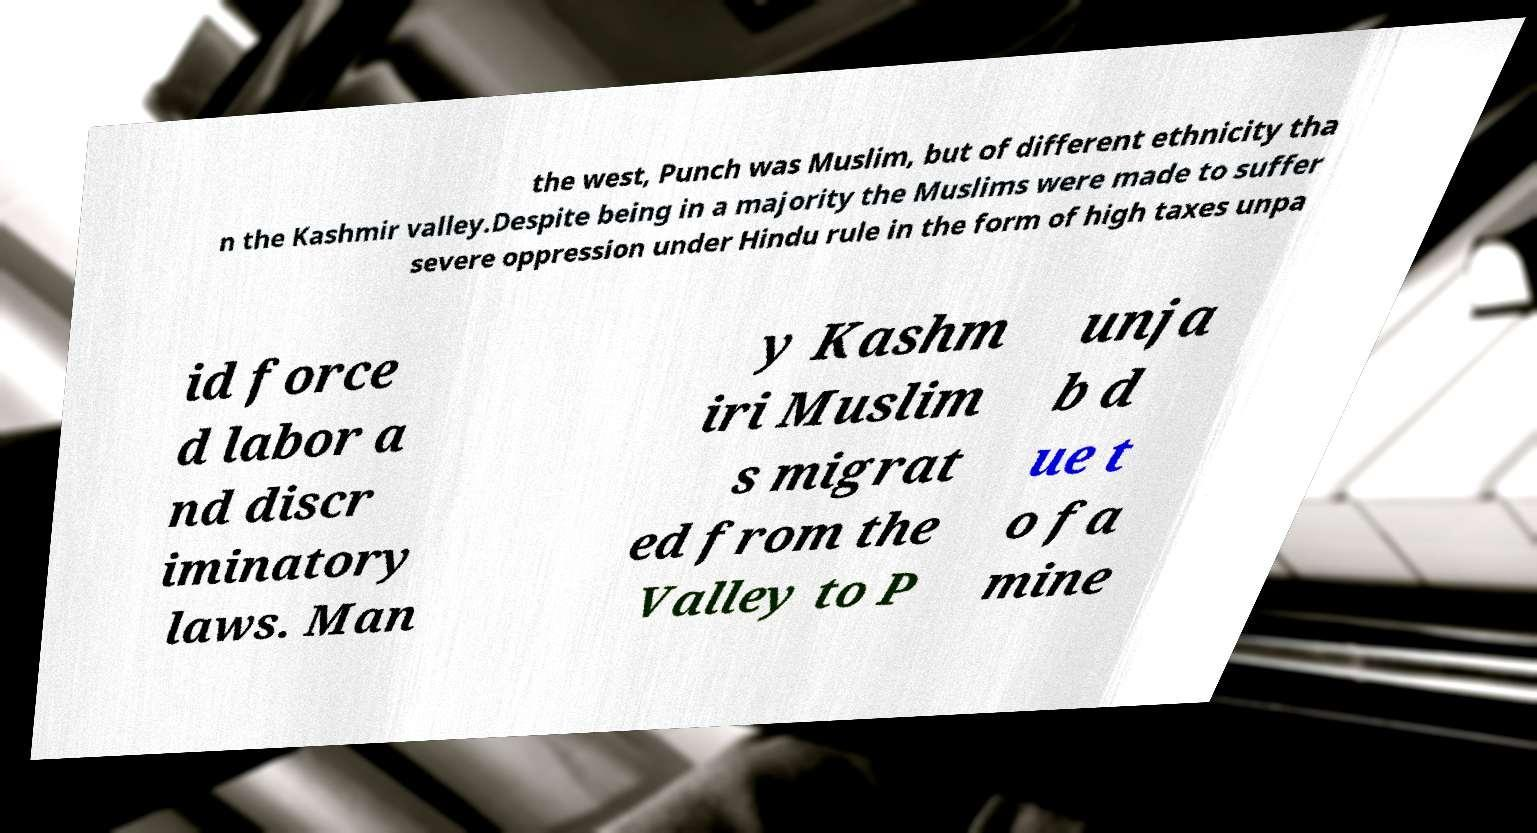What messages or text are displayed in this image? I need them in a readable, typed format. the west, Punch was Muslim, but of different ethnicity tha n the Kashmir valley.Despite being in a majority the Muslims were made to suffer severe oppression under Hindu rule in the form of high taxes unpa id force d labor a nd discr iminatory laws. Man y Kashm iri Muslim s migrat ed from the Valley to P unja b d ue t o fa mine 